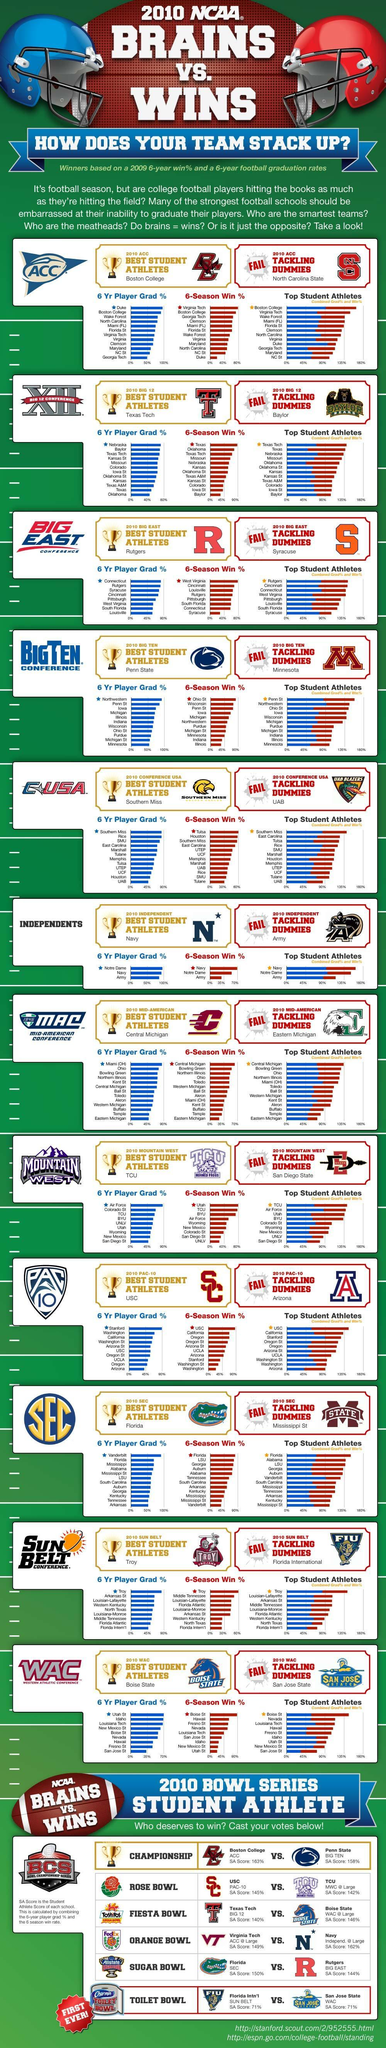Which were the top three ACC colleges with respect to their grad%?
Answer the question with a short phrase. Duke, Boston College, Wake Forest Which were the two schools that participated in the Rose Bowl series USC, TCU How many Big 12 colleges, had win% of less than 45%? 3 Which ACC college had win % of less than 40% in 2010? Duke Which ACC college received the highest Grad % in 2010? Duke Which were the top three ACC colleges with respect to their win%? Virginia Tech, Boston College, Georgia Tech Which were the top 3 ACC colleges under 'Top Student Athletes'? Boston College, Virginia Tech, Wake Forest To which conference does Minnesota belong? Big Ten conference Which Big East college stood among the top 3 in grad%, but was at the bottom for win%? Syracuse Who received  higher SA score in the Rose bowl series? USC Which Big 12 college had the highest Win% in 2010? Texas What was the SA score of Boston College? 163% How many bowl series are mentioned? 5 Which college was awarded the 2010 Big 12 Best Student Athletes? Texas Tech Which ACC college received the highest Win % in 2010? Virginia Tech Which are the first 3 football conferences mentioned? ACC, BIG 12, BIG EAST Which two schools have an SA score above 160%? Boston College, Navy Who has a higher SA score Boston College or Penn State? Boston College How many member colleges are there in 'Independents'? 3 Which ACC college stood "second"  with respect to both grad% and win% ? Boston College Which college was awarded the 2010 ACC Best Student Athletes? Boston College Which Big 12 college, stood among the top 3, in all the categories -  grad %,  win % and "top student athletes"? Texas Tech Which were the two schools in the Sugar Bowl series? Florida, Rutgers Which were the two schools that participated in the Fiesta Bowl series? Texas Tech, Boise State Which college was awarded the 2010 Big 12 Tackling Dummies? Baylor Which college was awarded the 2010 ACC Tackling Dummies? North Carolina State To which conference does Connecticut belong? Big East Which are the three members of Independents? Notre Dame, Navy, Army Which ACC college had a Grad % of less than 50% in 2010? Georgia Tech Which college was awarded the 2010 Big East Best Student Athletes? Rutgers Which college was awarded the 2010 Big East Tackling Dummies? Syracuse Which was the two schools with the lowest SA scores? Florida Intn'l, San Jose State Which Big 12 college had the highest grad% in 2010? Nebraska 